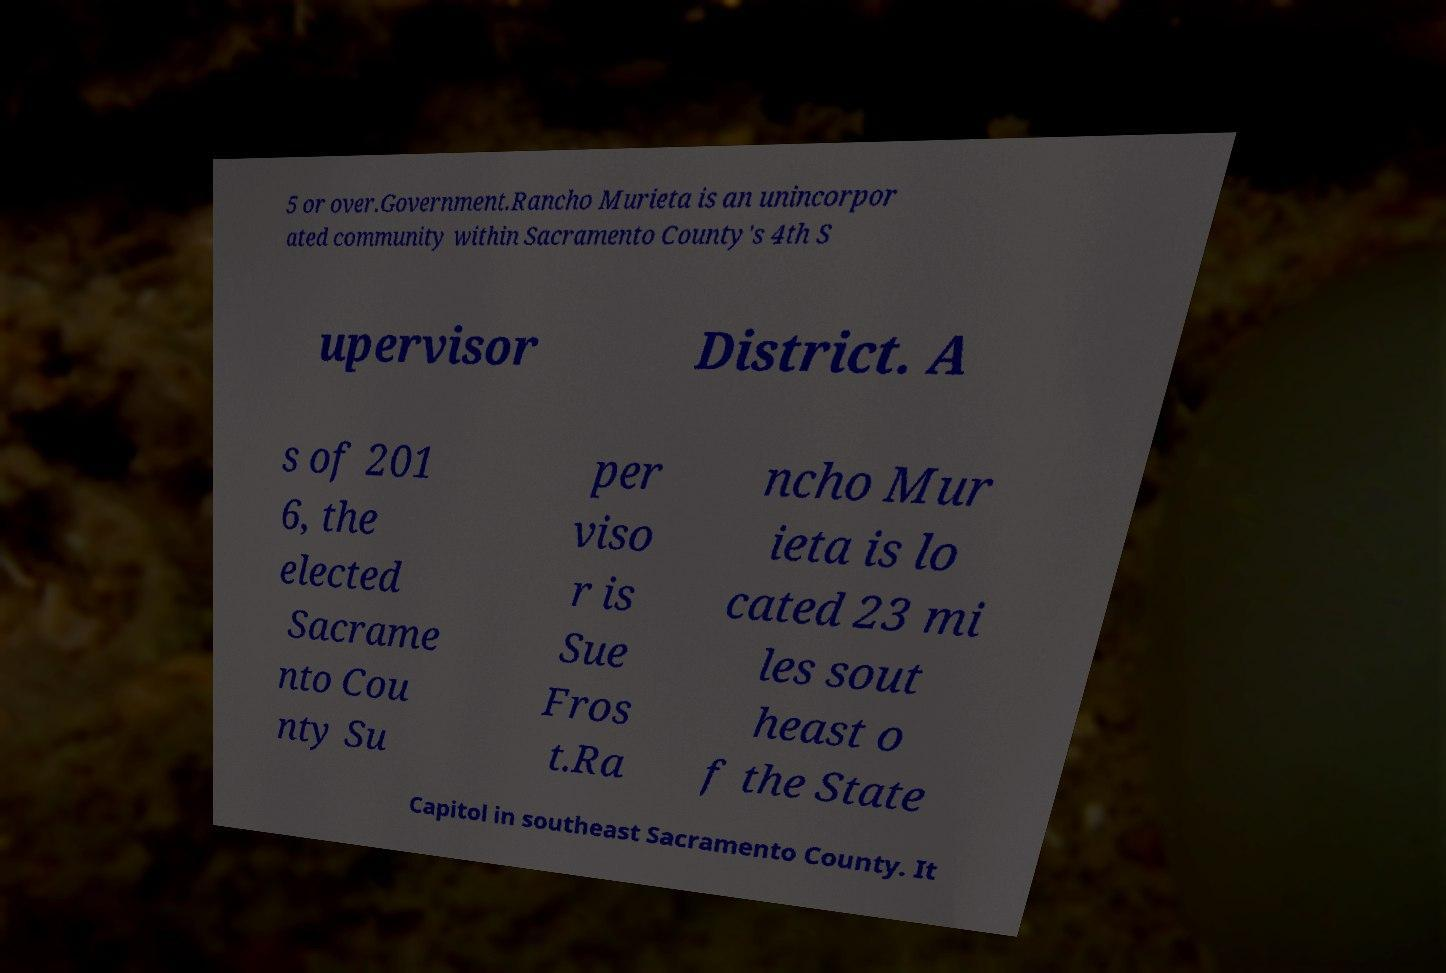Please read and relay the text visible in this image. What does it say? 5 or over.Government.Rancho Murieta is an unincorpor ated community within Sacramento County's 4th S upervisor District. A s of 201 6, the elected Sacrame nto Cou nty Su per viso r is Sue Fros t.Ra ncho Mur ieta is lo cated 23 mi les sout heast o f the State Capitol in southeast Sacramento County. It 